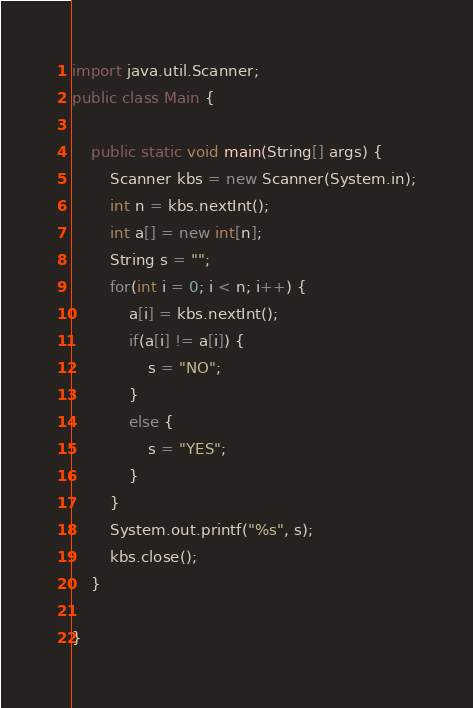Convert code to text. <code><loc_0><loc_0><loc_500><loc_500><_Java_>import java.util.Scanner;
public class Main {
	
	public static void main(String[] args) {
		Scanner kbs = new Scanner(System.in);
		int n = kbs.nextInt();
		int a[] = new int[n];
		String s = "";
		for(int i = 0; i < n; i++) {
			a[i] = kbs.nextInt();
			if(a[i] != a[i]) {
				s = "NO";
			}
			else {
				s = "YES";
			}
		}
		System.out.printf("%s", s);
		kbs.close();
	}

}
</code> 